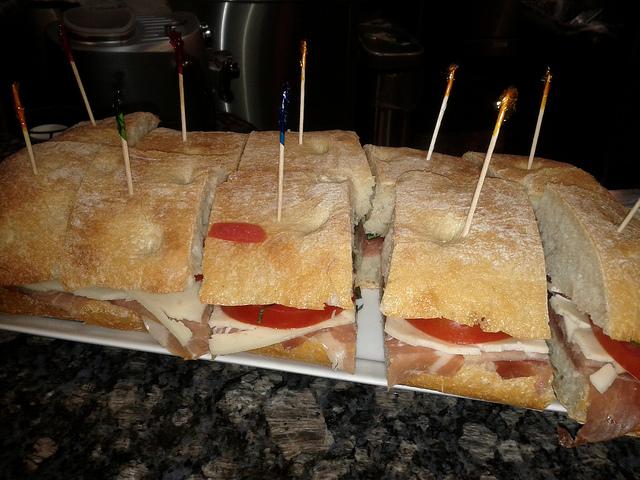How many people could eat this?
Answer briefly. 10. What type of sandwich is this?
Write a very short answer. Submarine. How many sandwich pieces are there?
Short answer required. 10. 